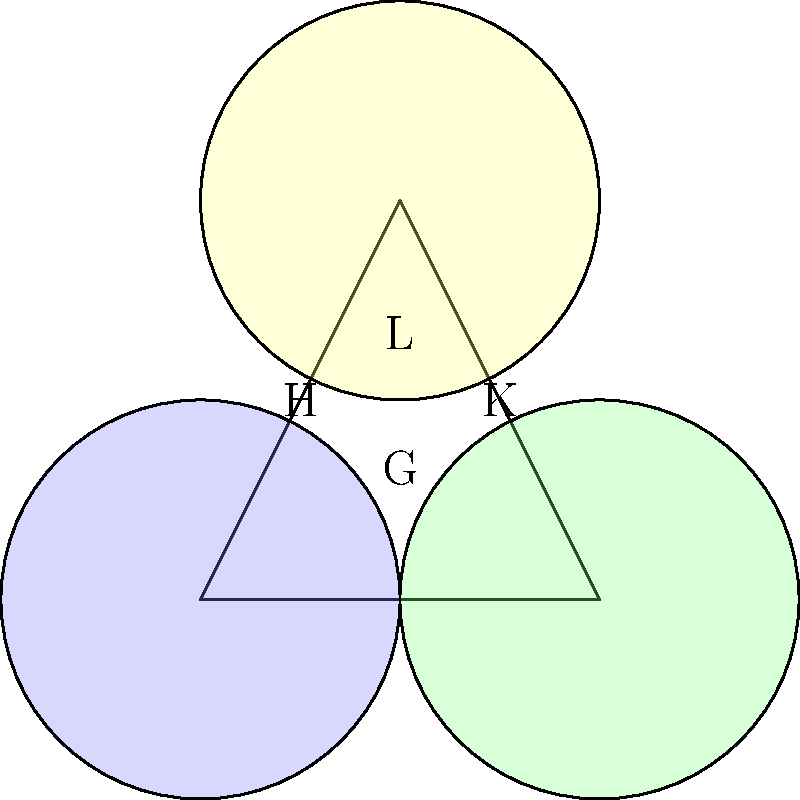In the Venn diagram above, a group G is represented by the entire triangle. Subgroups H, K, and L are represented by the blue, green, and yellow circles, respectively. How many distinct intersections of subgroups are visible in this diagram, excluding the intersections with G itself? To solve this problem, we need to analyze the Venn diagram and count the distinct intersections of subgroups:

1. First, let's identify the possible intersections:
   - H ∩ K (blue and green)
   - H ∩ L (blue and yellow)
   - K ∩ L (green and yellow)
   - H ∩ K ∩ L (blue, green, and yellow)

2. Now, let's count how many of these intersections are visible in the diagram:
   - H ∩ K: visible
   - H ∩ L: visible
   - K ∩ L: visible
   - H ∩ K ∩ L: visible

3. We can see that all four possible intersections are present in the diagram.

4. Note that we are not counting intersections with G itself, as G represents the entire group and encompasses all subgroups.

Therefore, the total number of distinct intersections of subgroups visible in this diagram is 4.
Answer: 4 